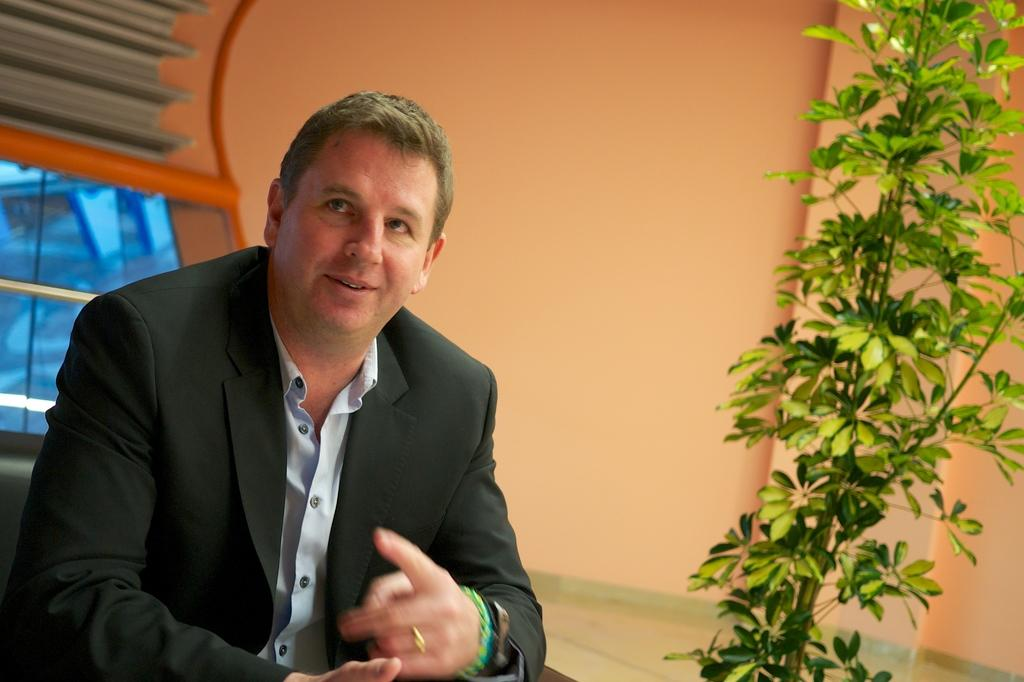Who or what is the main subject in the image? There is a person in the image. What is the person wearing? The person is wearing a suit. Where is the person located in the image? The person is sitting in front of a table. What is in front of the person? There is a plant in front of the person. How many tanks are visible in the image? There are no tanks present in the image. What type of berry is growing on the plant in front of the person? There is no berry growing on the plant in front of the person; it is not mentioned in the provided facts. 